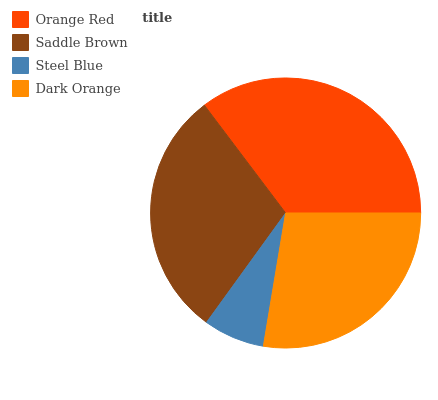Is Steel Blue the minimum?
Answer yes or no. Yes. Is Orange Red the maximum?
Answer yes or no. Yes. Is Saddle Brown the minimum?
Answer yes or no. No. Is Saddle Brown the maximum?
Answer yes or no. No. Is Orange Red greater than Saddle Brown?
Answer yes or no. Yes. Is Saddle Brown less than Orange Red?
Answer yes or no. Yes. Is Saddle Brown greater than Orange Red?
Answer yes or no. No. Is Orange Red less than Saddle Brown?
Answer yes or no. No. Is Saddle Brown the high median?
Answer yes or no. Yes. Is Dark Orange the low median?
Answer yes or no. Yes. Is Dark Orange the high median?
Answer yes or no. No. Is Orange Red the low median?
Answer yes or no. No. 